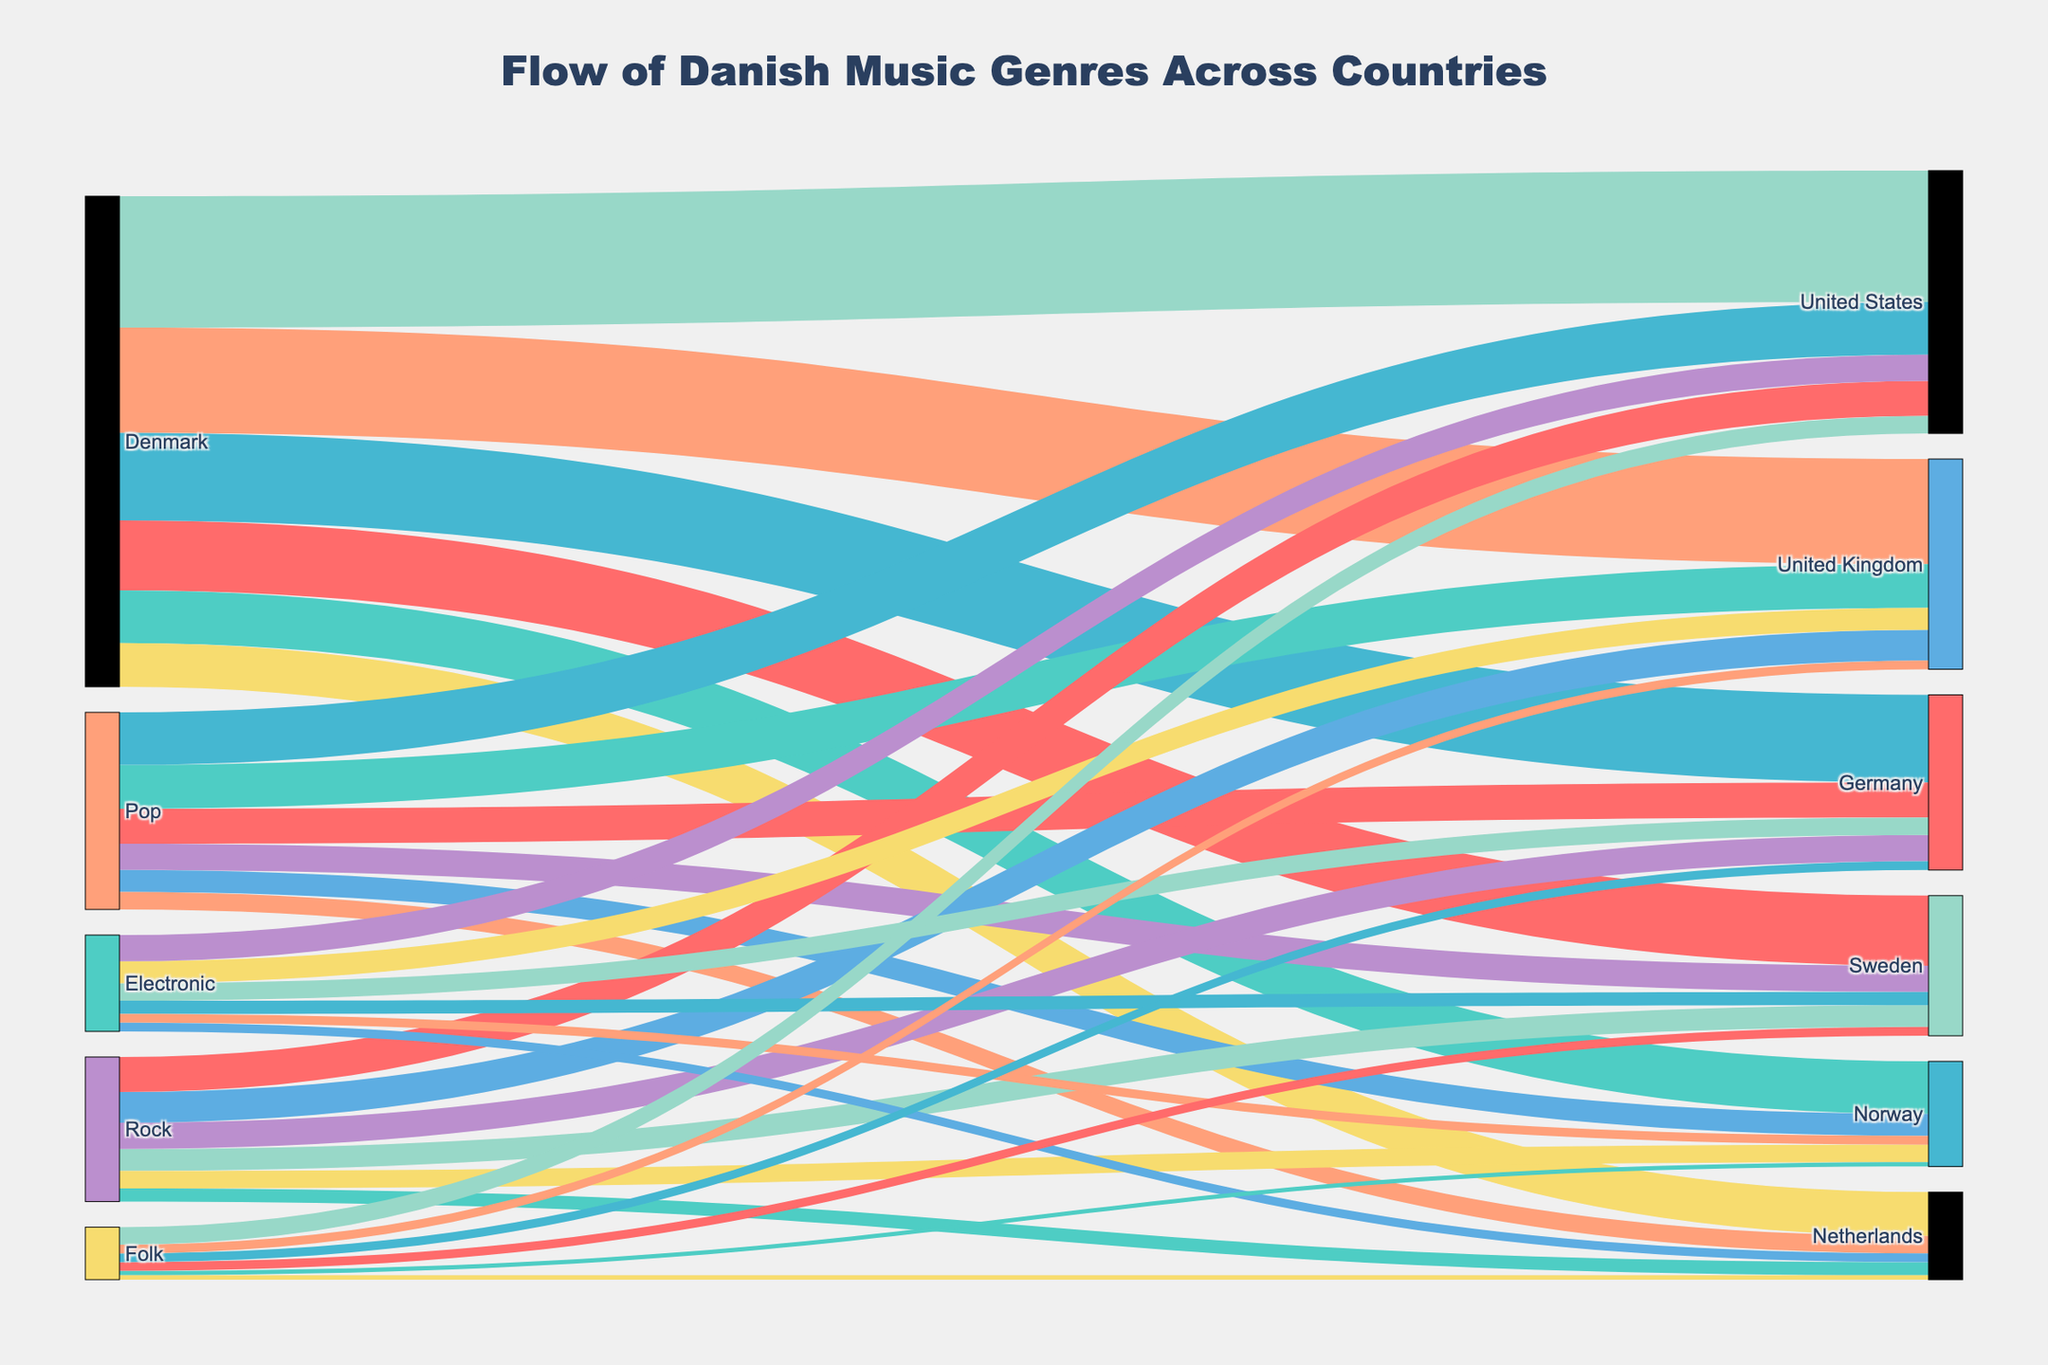What's the title of the figure? The title is usually located at the top center of the figure.
Answer: Flow of Danish Music Genres Across Countries Which country has the highest flow value from Denmark? By analyzing the flow values associated with Denmark, the highest value can be identified. Denmark to the United States has a value of 15,000, which is the highest.
Answer: United States What are the total values of Danish music flowing into Sweden? Adding the flow values from Denmark to Sweden and the flows of Pop, Rock, Electronic, and Folk to Sweden: 8000 + 3000 + 2500 + 1500 + 1000 = 16000.
Answer: 16000 Does Pop music have a higher flow value into Germany or the United Kingdom? Comparing the flow values for Pop music into Germany (4000) and the United Kingdom (5000), Pop music has a higher value into the United Kingdom.
Answer: United Kingdom What is the combined value of Rock and Folk music flowing into the United States? Adding the flow values of Rock and Folk music into the United States: 4000 (Rock) + 2000 (Folk) = 6000.
Answer: 6000 Which genre has the lowest flow value into the Netherlands? By checking the values for Pop, Rock, Electronic, and Folk into the Netherlands, Folk and Electronic both have the lowest flow value of 5000 each.
Answer: Folk and Electronic How much more music flows from Denmark to the United Kingdom compared to Germany? The flow value from Denmark to the United Kingdom is 12000, and to Germany is 10000. The difference is 12000 - 10000 = 2000.
Answer: 2000 Do more Danish electronic music flows into Norway or Netherlands? By comparing the flow values of Danish electronic music into Norway (1000) and the Netherlands (1000), they are equal.
Answer: They are equal What's the total value for all genres flowing from Denmark to Norway? Summing the individual genres' values from Denmark to Norway: 6000 (Denmark) + 2500 (Pop) + 2000 (Rock) + 1000 (Electronic) + 500 (Folk) = 12000.
Answer: 12000 Which genre has the highest flow value into the United States? By checking the flow values of Pop (6000), Rock (4000), Electronic (3000), and Folk (2000) into the United States, Pop has the highest value at 6000.
Answer: Pop 